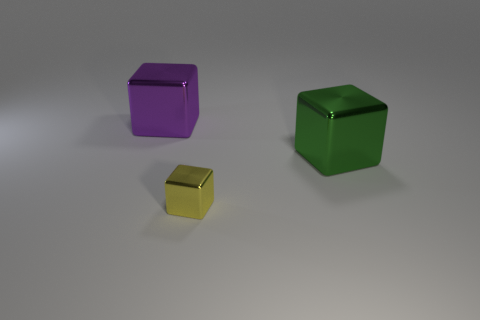Are there any large purple objects that have the same shape as the yellow thing?
Offer a terse response. Yes. How many small yellow blocks are there?
Offer a very short reply. 1. What number of large objects are either yellow metal things or green metal balls?
Provide a succinct answer. 0. There is a shiny thing that is behind the large metallic thing that is to the right of the big purple cube behind the yellow thing; what is its color?
Provide a succinct answer. Purple. What number of other things are the same color as the tiny metallic cube?
Your answer should be very brief. 0. What number of matte objects are either small yellow things or large red cylinders?
Give a very brief answer. 0. The purple shiny object that is the same shape as the yellow thing is what size?
Offer a very short reply. Large. Is the number of cubes behind the large green cube greater than the number of large blue metal cubes?
Your answer should be very brief. Yes. Do the large object to the right of the small yellow shiny thing and the yellow thing have the same material?
Your answer should be very brief. Yes. There is a shiny thing that is behind the large object in front of the big thing behind the green shiny thing; how big is it?
Give a very brief answer. Large. 